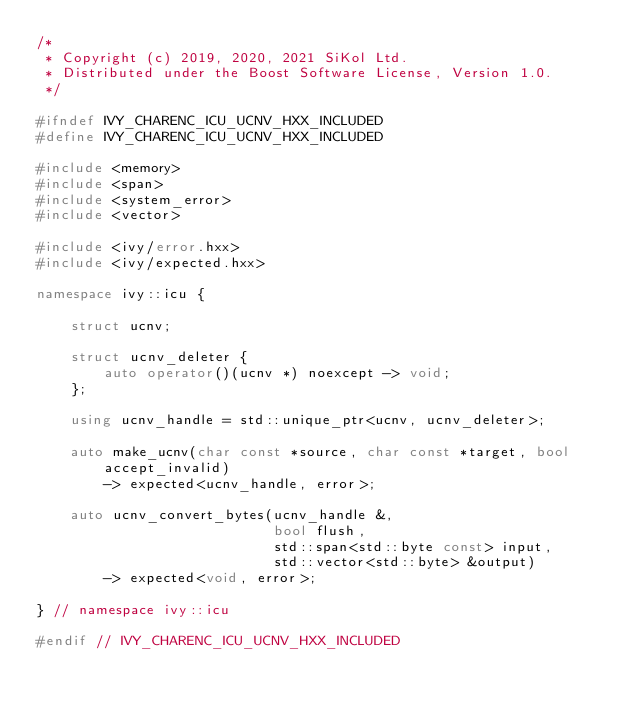<code> <loc_0><loc_0><loc_500><loc_500><_C++_>/*
 * Copyright (c) 2019, 2020, 2021 SiKol Ltd.
 * Distributed under the Boost Software License, Version 1.0.
 */

#ifndef IVY_CHARENC_ICU_UCNV_HXX_INCLUDED
#define IVY_CHARENC_ICU_UCNV_HXX_INCLUDED

#include <memory>
#include <span>
#include <system_error>
#include <vector>

#include <ivy/error.hxx>
#include <ivy/expected.hxx>

namespace ivy::icu {

    struct ucnv;

    struct ucnv_deleter {
        auto operator()(ucnv *) noexcept -> void;
    };

    using ucnv_handle = std::unique_ptr<ucnv, ucnv_deleter>;

    auto make_ucnv(char const *source, char const *target, bool accept_invalid)
        -> expected<ucnv_handle, error>;

    auto ucnv_convert_bytes(ucnv_handle &,
                            bool flush,
                            std::span<std::byte const> input,
                            std::vector<std::byte> &output)
        -> expected<void, error>;

} // namespace ivy::icu

#endif // IVY_CHARENC_ICU_UCNV_HXX_INCLUDED
</code> 